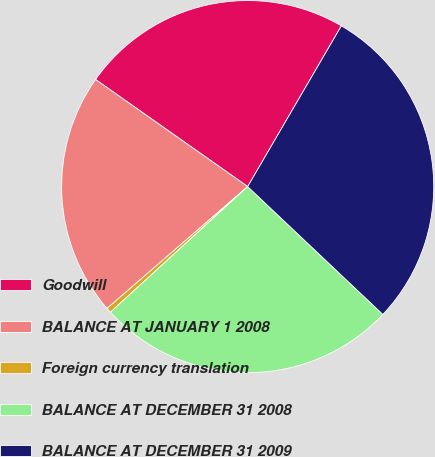<chart> <loc_0><loc_0><loc_500><loc_500><pie_chart><fcel>Goodwill<fcel>BALANCE AT JANUARY 1 2008<fcel>Foreign currency translation<fcel>BALANCE AT DECEMBER 31 2008<fcel>BALANCE AT DECEMBER 31 2009<nl><fcel>23.64%<fcel>21.13%<fcel>0.43%<fcel>26.15%<fcel>28.66%<nl></chart> 